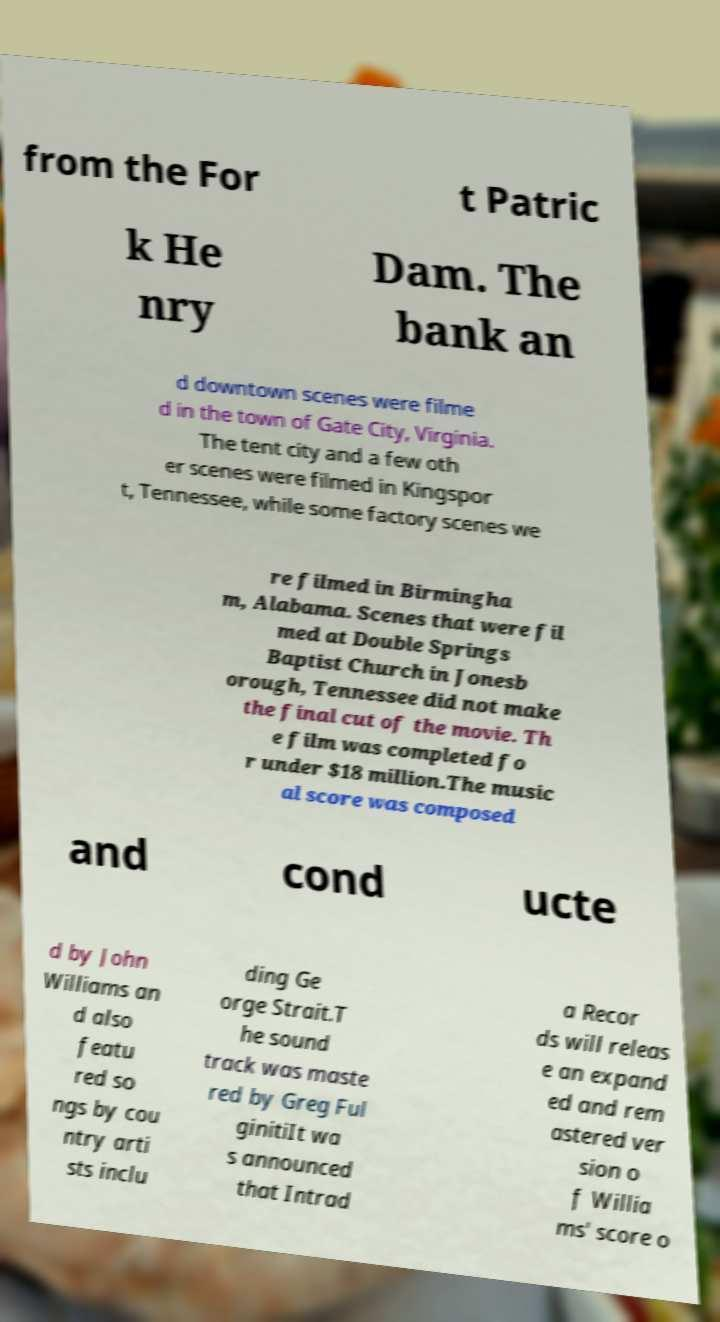Could you extract and type out the text from this image? from the For t Patric k He nry Dam. The bank an d downtown scenes were filme d in the town of Gate City, Virginia. The tent city and a few oth er scenes were filmed in Kingspor t, Tennessee, while some factory scenes we re filmed in Birmingha m, Alabama. Scenes that were fil med at Double Springs Baptist Church in Jonesb orough, Tennessee did not make the final cut of the movie. Th e film was completed fo r under $18 million.The music al score was composed and cond ucte d by John Williams an d also featu red so ngs by cou ntry arti sts inclu ding Ge orge Strait.T he sound track was maste red by Greg Ful ginitiIt wa s announced that Intrad a Recor ds will releas e an expand ed and rem astered ver sion o f Willia ms' score o 